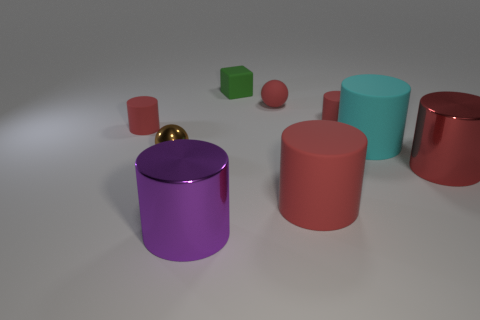Subtract all blue cubes. How many red cylinders are left? 4 Subtract all large purple cylinders. How many cylinders are left? 5 Subtract all cyan cylinders. How many cylinders are left? 5 Subtract 3 cylinders. How many cylinders are left? 3 Subtract all blue cylinders. Subtract all yellow cubes. How many cylinders are left? 6 Add 1 small red objects. How many objects exist? 10 Subtract all spheres. How many objects are left? 7 Add 4 gray metallic balls. How many gray metallic balls exist? 4 Subtract 0 brown cylinders. How many objects are left? 9 Subtract all small brown objects. Subtract all big red things. How many objects are left? 6 